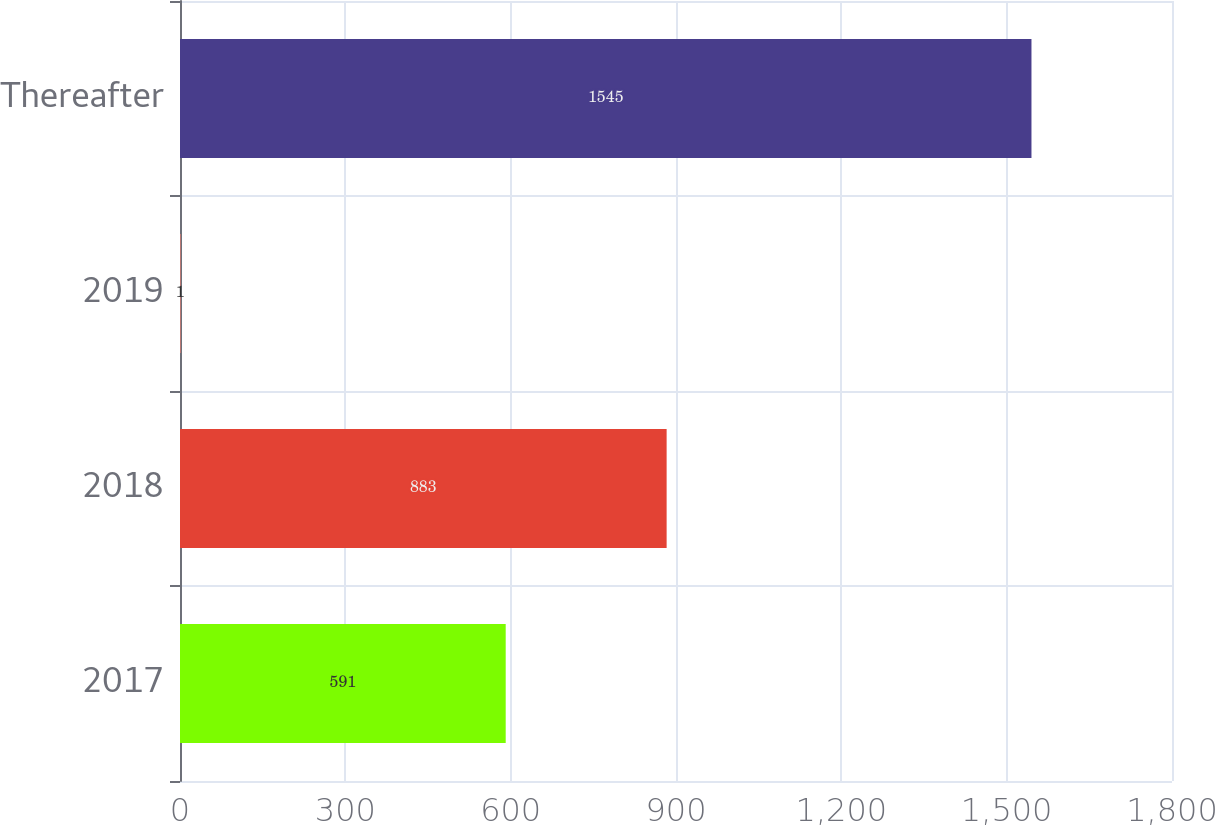Convert chart. <chart><loc_0><loc_0><loc_500><loc_500><bar_chart><fcel>2017<fcel>2018<fcel>2019<fcel>Thereafter<nl><fcel>591<fcel>883<fcel>1<fcel>1545<nl></chart> 